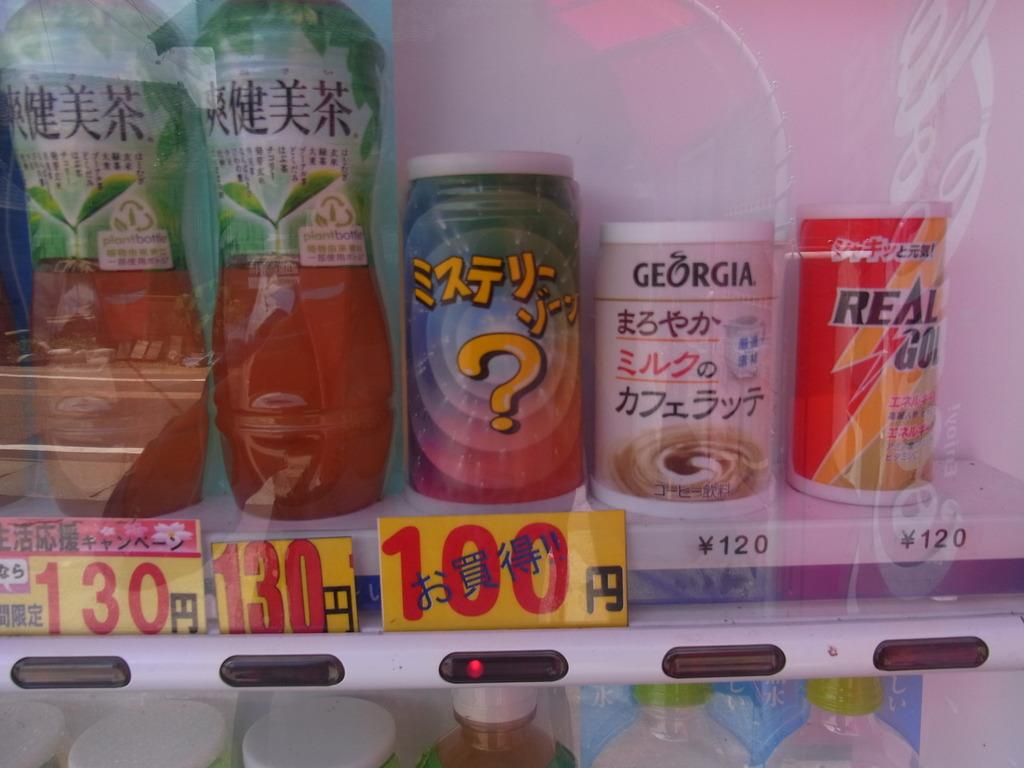What is the main object in the image? There is a vending machine in the image. What type of items can be found inside the vending machine? The vending machine contains juice bottles. What type of clouds can be seen in the image? There are no clouds visible in the image, as it only features a vending machine with juice bottles. 